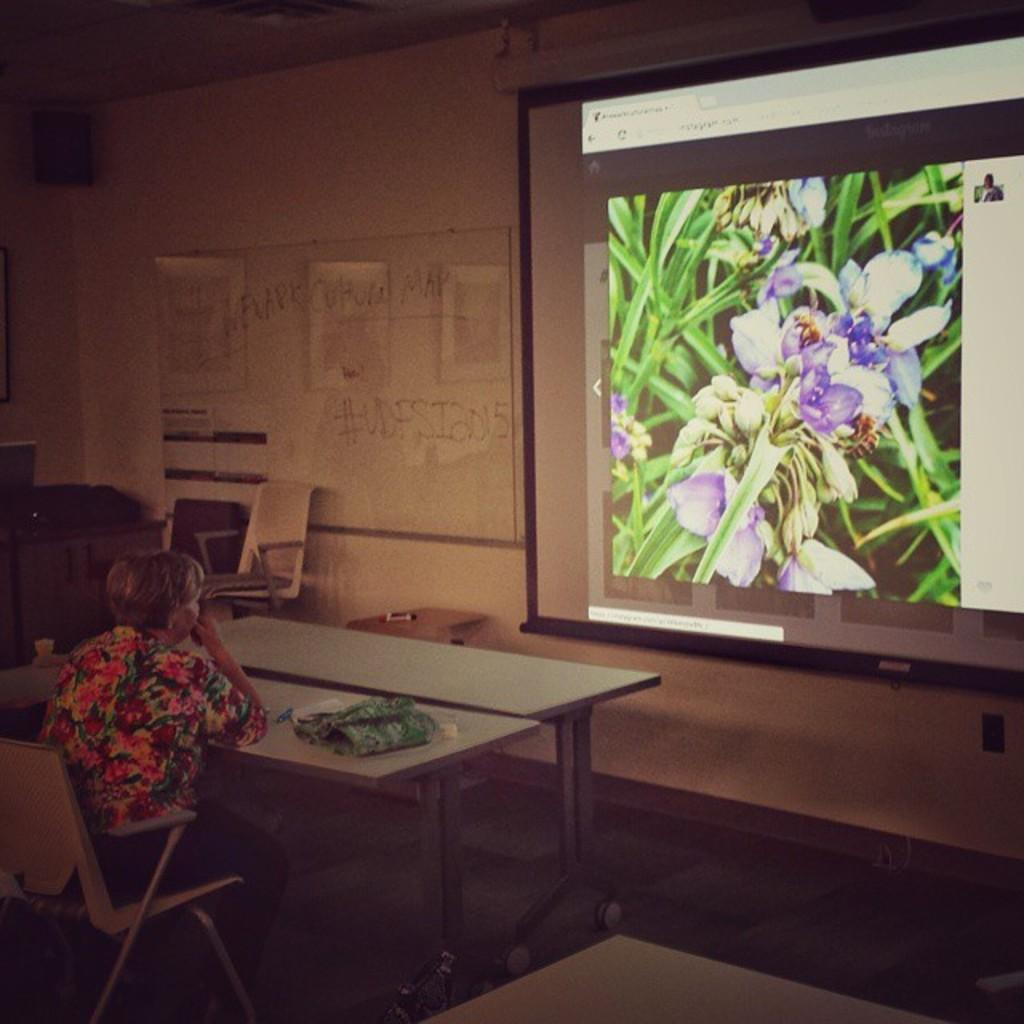Who is the person on the left side of the image? There is a woman on the left side of the image. What is the woman doing in the image? The woman is sitting on a chair. What is on the table in the image? There is a cloth on the table. What can be seen in the background of the image? In the background, there are posters and a wall visible. What is the purpose of the projector in the background? A projector is present in the background, but its purpose cannot be determined from the image alone. What type of competition is the woman participating in, as seen in the image? There is no competition visible in the image; it only shows a woman sitting on a chair with a table and posters in the background. 